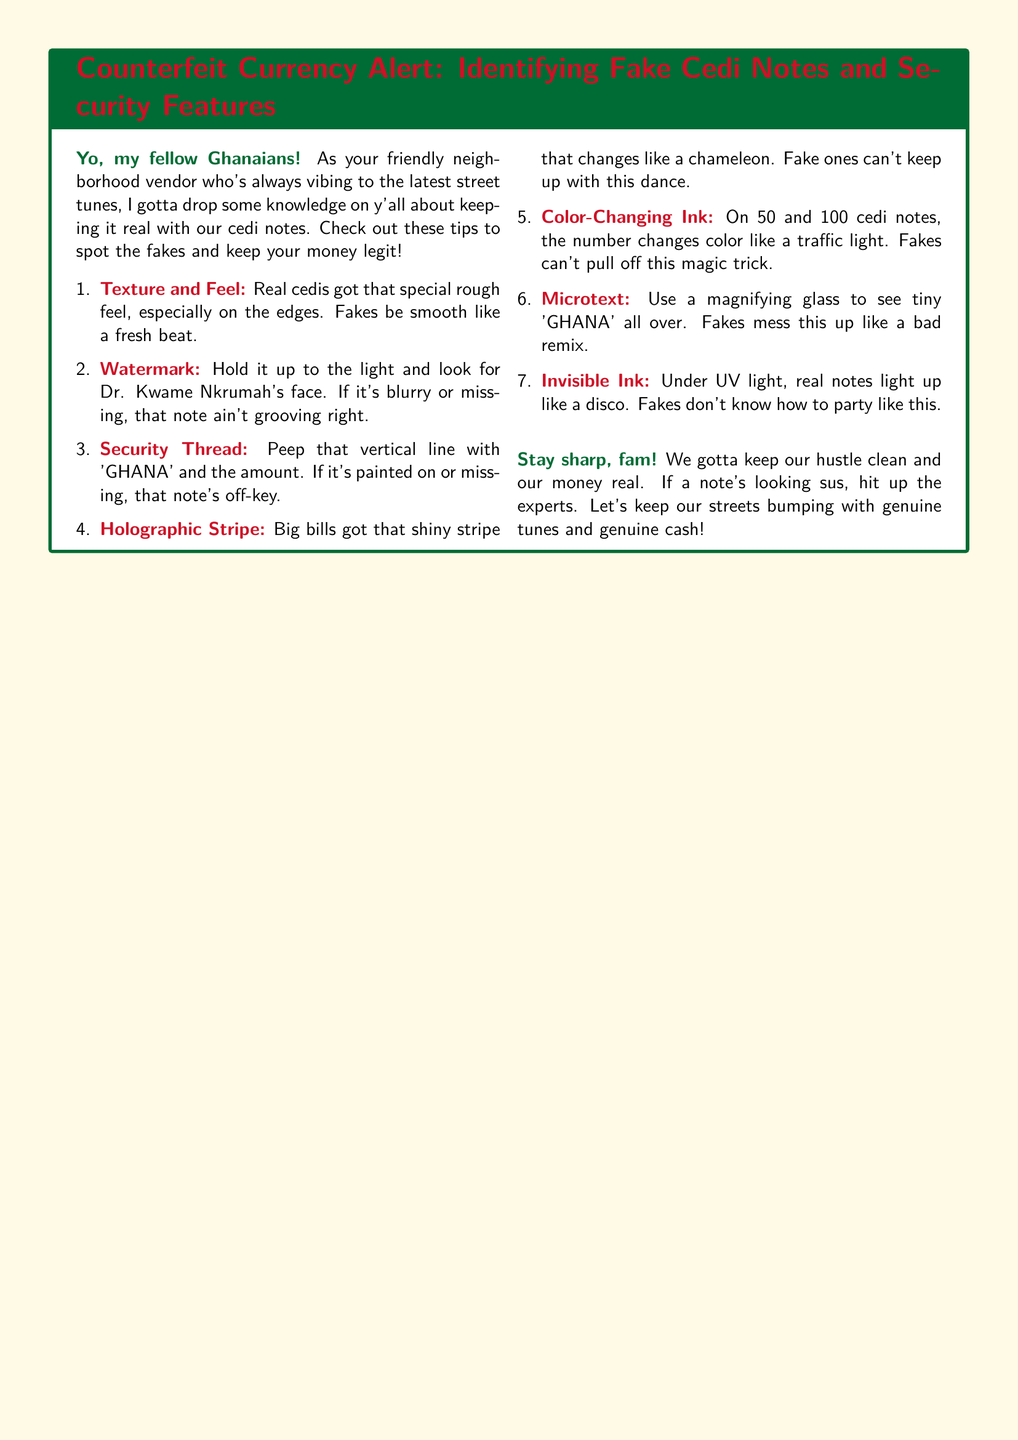what is the title of the document? The title is provided at the beginning of the document inside the tcolorbox, specifically formatted with a specific color scheme.
Answer: Counterfeit Currency Alert: Identifying Fake Cedi Notes and Security Features who is featured on the watermark? The watermark is a notable security feature of the cedi notes, specifically mentioning who is depicted when held against the light.
Answer: Dr. Kwame Nkrumah what should the texture of real cedis feel like? The document emphasizes that real cedis have a specific texture, indicating how they differ from counterfeit notes.
Answer: rough what security feature changes color on certain notes? The document specifies that a specific security feature on 50 and 100 cedi notes changes color, highlighting its importance in identifying genuine notes.
Answer: Color-Changing Ink what is visible under UV light? The document mentions a particular feature of real notes when exposed to UV light, which distinguishes them from fakes.
Answer: Invisible Ink what should you do if a note looks 'sus'? The document advises what actions to take if there's uncertainty about a note's authenticity based on its appearance.
Answer: hit up the experts how many main tips for identifying fake cedi notes are listed? The document lists a specific number of tips for identifying counterfeit currency, emphasizing their importance for the audience.
Answer: seven what is a sign of a counterfeit note regarding the security thread? The document describes how a genuine note's security thread should appear, providing clarity on what to check for.
Answer: vertical line with 'GHANA' and the amount 